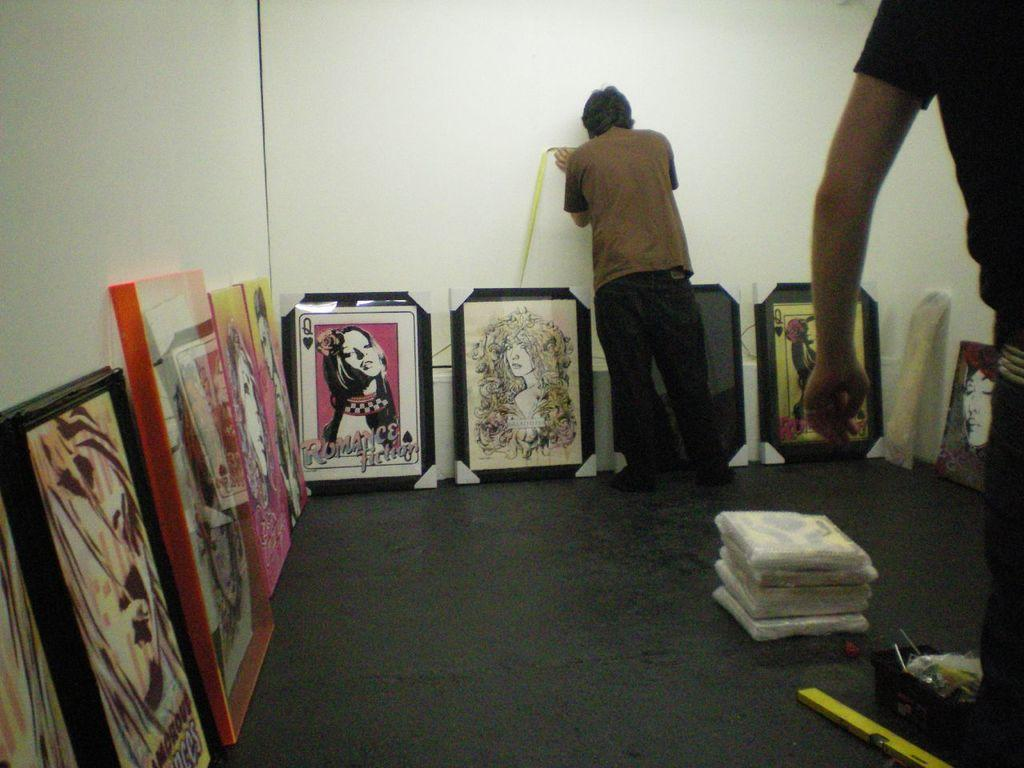<image>
Give a short and clear explanation of the subsequent image. A picture that says Romance Fiction depicts a queen of spades card with a woman's face. 